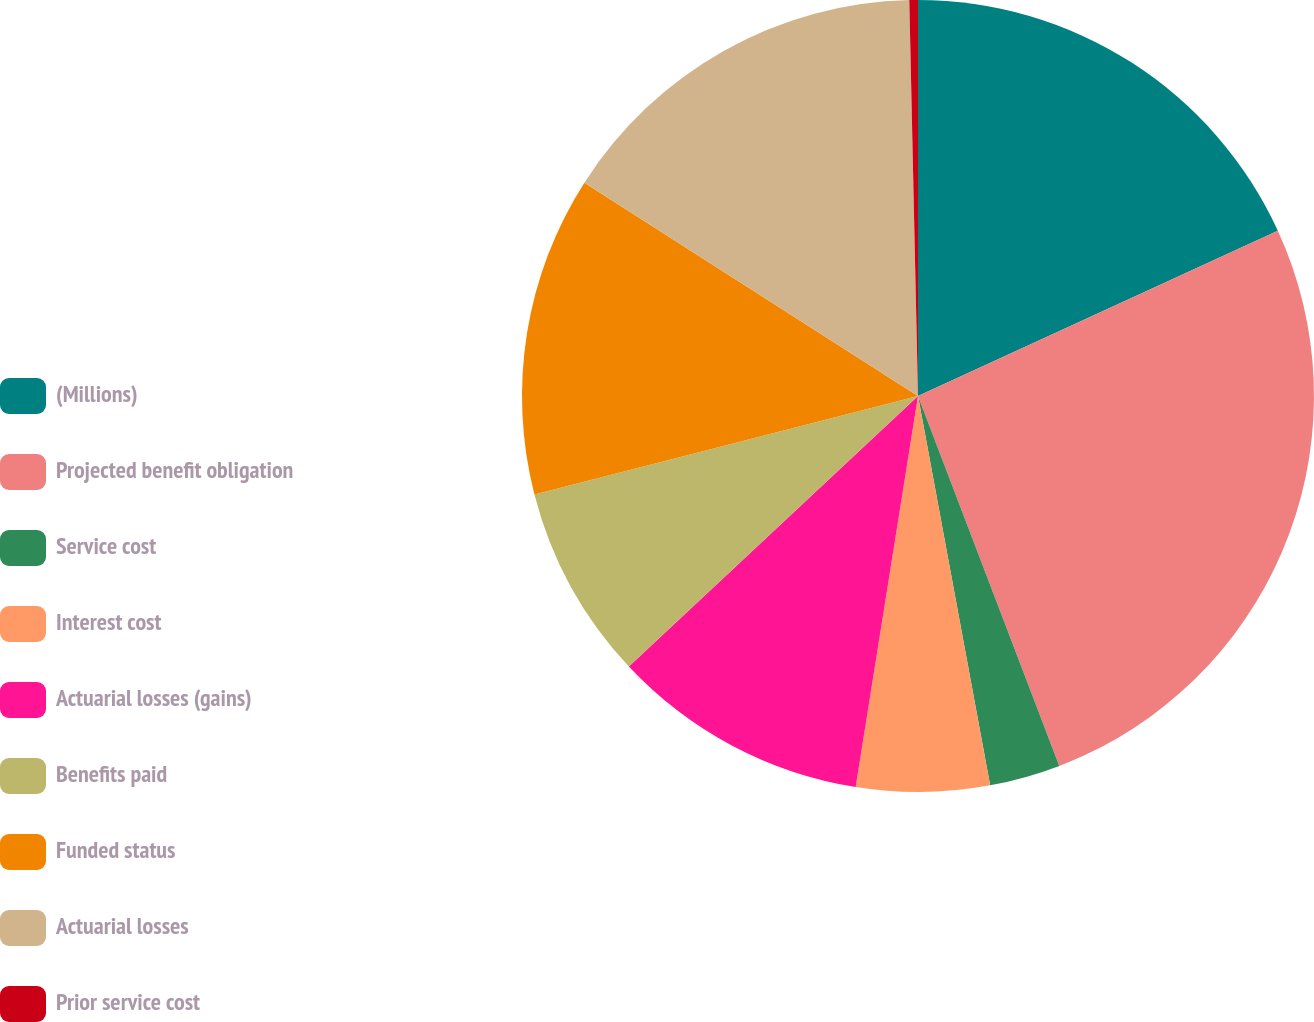Convert chart. <chart><loc_0><loc_0><loc_500><loc_500><pie_chart><fcel>(Millions)<fcel>Projected benefit obligation<fcel>Service cost<fcel>Interest cost<fcel>Actuarial losses (gains)<fcel>Benefits paid<fcel>Funded status<fcel>Actuarial losses<fcel>Prior service cost<nl><fcel>18.14%<fcel>26.04%<fcel>2.89%<fcel>5.43%<fcel>10.51%<fcel>7.97%<fcel>13.05%<fcel>15.59%<fcel>0.35%<nl></chart> 